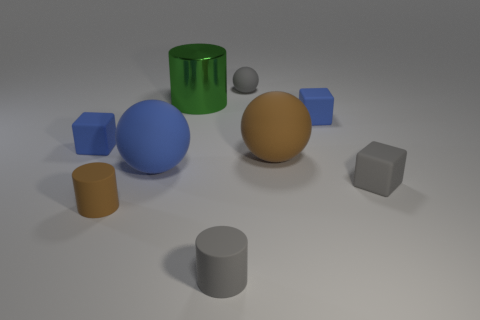What number of cyan objects are either small blocks or tiny matte balls?
Give a very brief answer. 0. Are there fewer large blue rubber balls that are left of the tiny gray rubber cube than small gray spheres to the right of the large brown rubber object?
Ensure brevity in your answer.  No. There is a green object; is it the same size as the block that is on the left side of the gray ball?
Give a very brief answer. No. What number of gray objects have the same size as the gray ball?
Give a very brief answer. 2. What number of tiny things are either green cylinders or matte cubes?
Your answer should be compact. 3. Is there a small yellow metallic cylinder?
Provide a short and direct response. No. Is the number of tiny matte cubes on the left side of the large blue object greater than the number of small blue matte cubes in front of the small brown thing?
Ensure brevity in your answer.  Yes. What color is the tiny matte thing that is on the left side of the tiny cylinder behind the tiny gray rubber cylinder?
Make the answer very short. Blue. Is there a rubber object of the same color as the small matte sphere?
Provide a short and direct response. Yes. There is a ball left of the small gray rubber cylinder to the right of the blue rubber cube to the left of the small sphere; what size is it?
Provide a short and direct response. Large. 